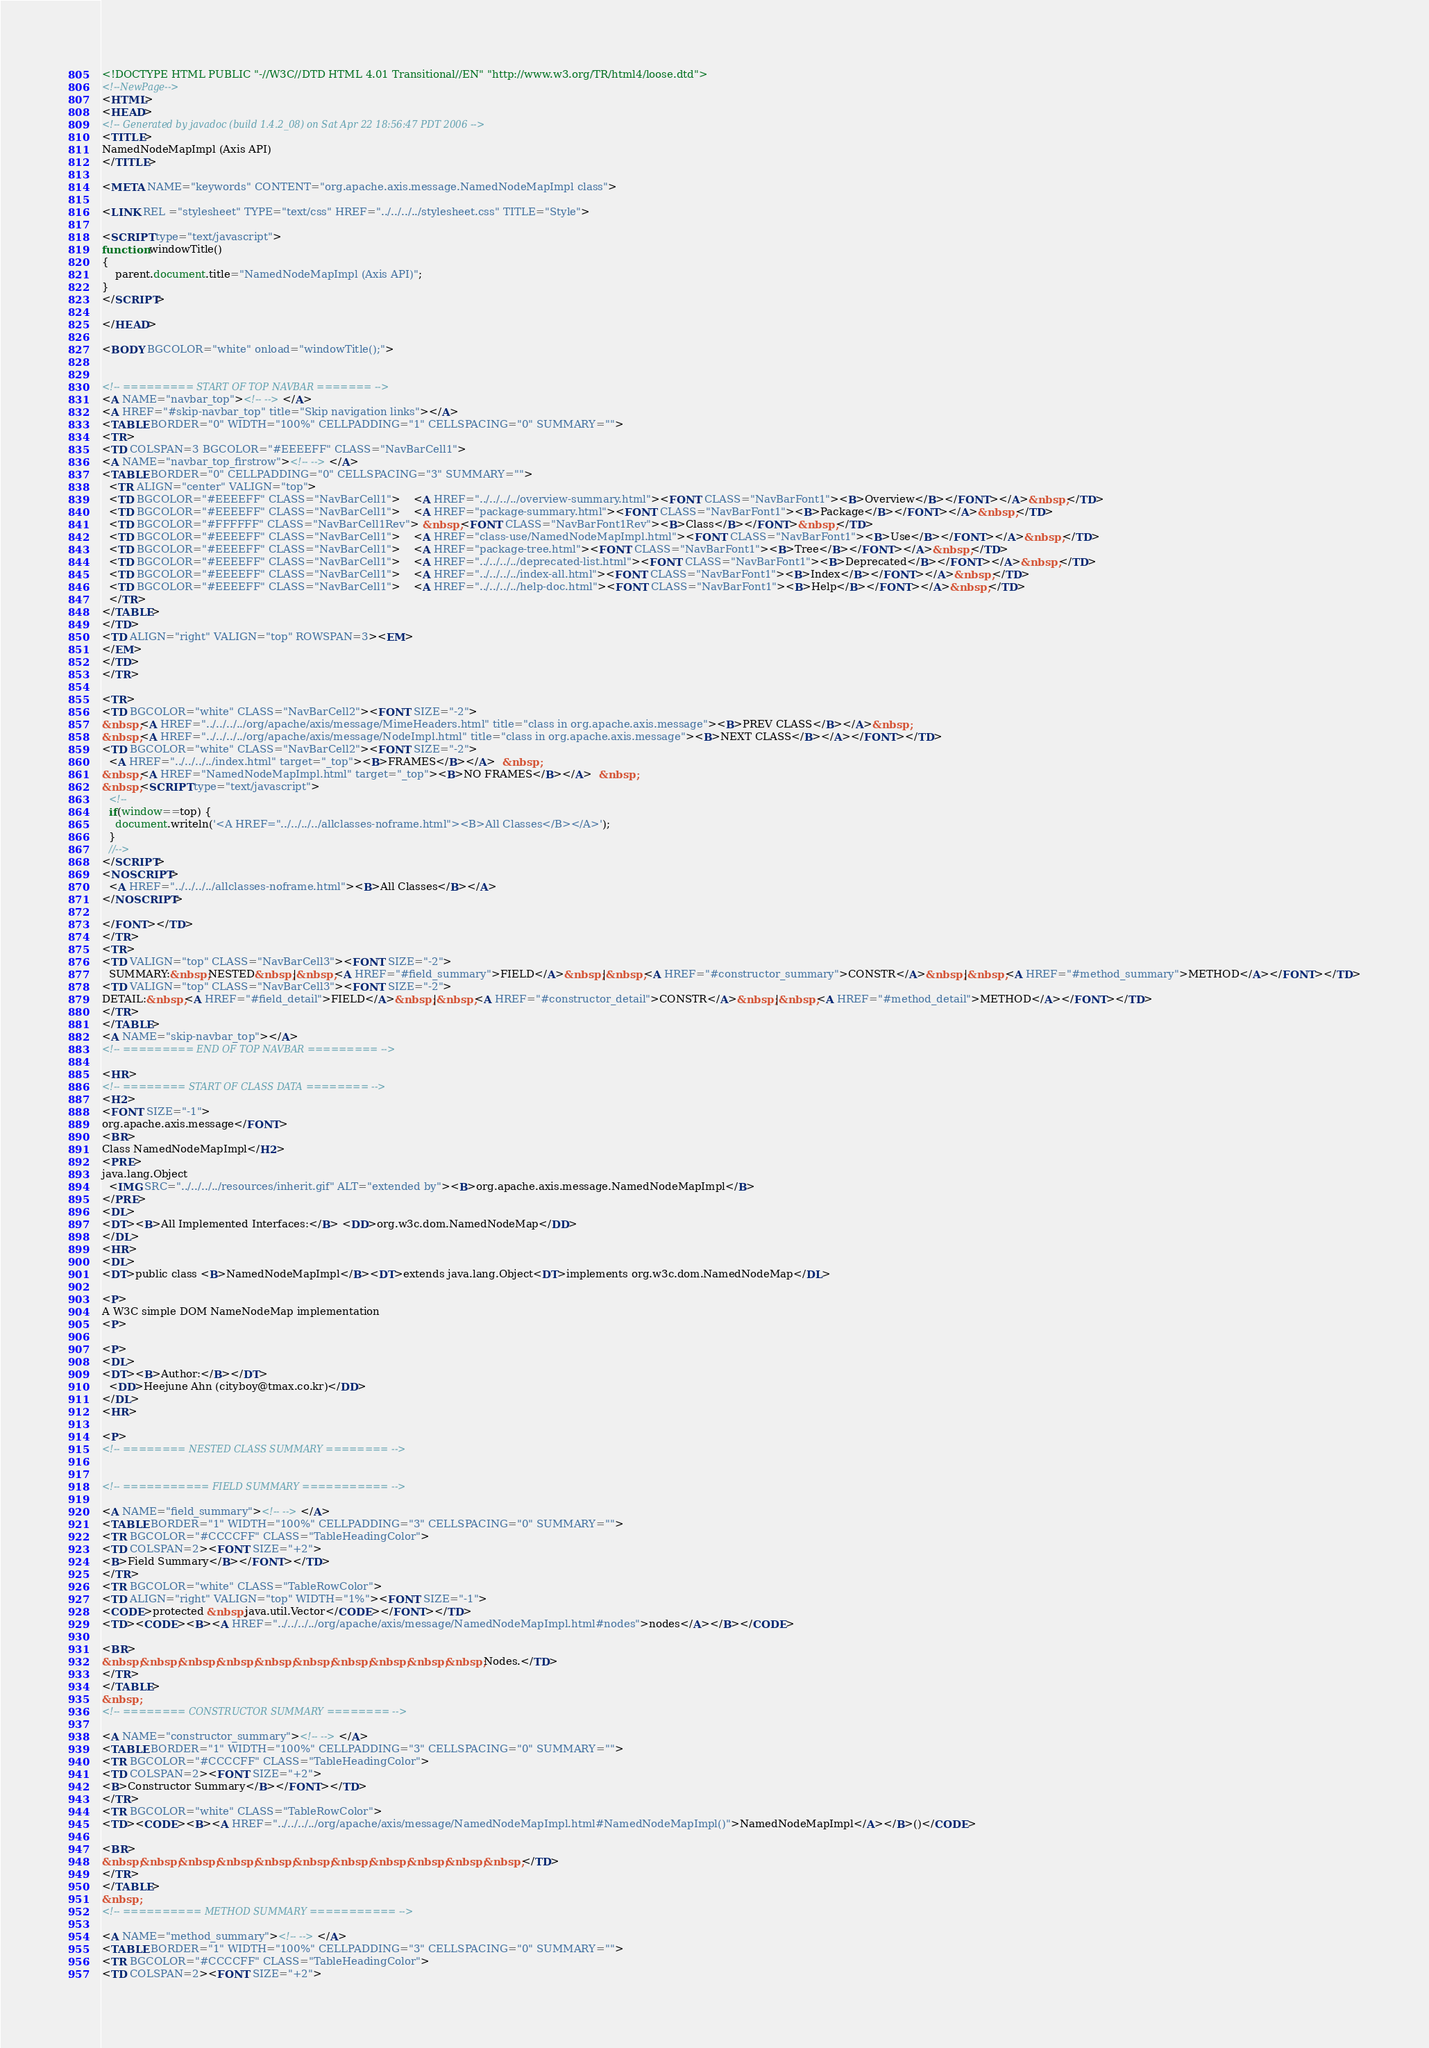<code> <loc_0><loc_0><loc_500><loc_500><_HTML_><!DOCTYPE HTML PUBLIC "-//W3C//DTD HTML 4.01 Transitional//EN" "http://www.w3.org/TR/html4/loose.dtd">
<!--NewPage-->
<HTML>
<HEAD>
<!-- Generated by javadoc (build 1.4.2_08) on Sat Apr 22 18:56:47 PDT 2006 -->
<TITLE>
NamedNodeMapImpl (Axis API)
</TITLE>

<META NAME="keywords" CONTENT="org.apache.axis.message.NamedNodeMapImpl class">

<LINK REL ="stylesheet" TYPE="text/css" HREF="../../../../stylesheet.css" TITLE="Style">

<SCRIPT type="text/javascript">
function windowTitle()
{
    parent.document.title="NamedNodeMapImpl (Axis API)";
}
</SCRIPT>

</HEAD>

<BODY BGCOLOR="white" onload="windowTitle();">


<!-- ========= START OF TOP NAVBAR ======= -->
<A NAME="navbar_top"><!-- --></A>
<A HREF="#skip-navbar_top" title="Skip navigation links"></A>
<TABLE BORDER="0" WIDTH="100%" CELLPADDING="1" CELLSPACING="0" SUMMARY="">
<TR>
<TD COLSPAN=3 BGCOLOR="#EEEEFF" CLASS="NavBarCell1">
<A NAME="navbar_top_firstrow"><!-- --></A>
<TABLE BORDER="0" CELLPADDING="0" CELLSPACING="3" SUMMARY="">
  <TR ALIGN="center" VALIGN="top">
  <TD BGCOLOR="#EEEEFF" CLASS="NavBarCell1">    <A HREF="../../../../overview-summary.html"><FONT CLASS="NavBarFont1"><B>Overview</B></FONT></A>&nbsp;</TD>
  <TD BGCOLOR="#EEEEFF" CLASS="NavBarCell1">    <A HREF="package-summary.html"><FONT CLASS="NavBarFont1"><B>Package</B></FONT></A>&nbsp;</TD>
  <TD BGCOLOR="#FFFFFF" CLASS="NavBarCell1Rev"> &nbsp;<FONT CLASS="NavBarFont1Rev"><B>Class</B></FONT>&nbsp;</TD>
  <TD BGCOLOR="#EEEEFF" CLASS="NavBarCell1">    <A HREF="class-use/NamedNodeMapImpl.html"><FONT CLASS="NavBarFont1"><B>Use</B></FONT></A>&nbsp;</TD>
  <TD BGCOLOR="#EEEEFF" CLASS="NavBarCell1">    <A HREF="package-tree.html"><FONT CLASS="NavBarFont1"><B>Tree</B></FONT></A>&nbsp;</TD>
  <TD BGCOLOR="#EEEEFF" CLASS="NavBarCell1">    <A HREF="../../../../deprecated-list.html"><FONT CLASS="NavBarFont1"><B>Deprecated</B></FONT></A>&nbsp;</TD>
  <TD BGCOLOR="#EEEEFF" CLASS="NavBarCell1">    <A HREF="../../../../index-all.html"><FONT CLASS="NavBarFont1"><B>Index</B></FONT></A>&nbsp;</TD>
  <TD BGCOLOR="#EEEEFF" CLASS="NavBarCell1">    <A HREF="../../../../help-doc.html"><FONT CLASS="NavBarFont1"><B>Help</B></FONT></A>&nbsp;</TD>
  </TR>
</TABLE>
</TD>
<TD ALIGN="right" VALIGN="top" ROWSPAN=3><EM>
</EM>
</TD>
</TR>

<TR>
<TD BGCOLOR="white" CLASS="NavBarCell2"><FONT SIZE="-2">
&nbsp;<A HREF="../../../../org/apache/axis/message/MimeHeaders.html" title="class in org.apache.axis.message"><B>PREV CLASS</B></A>&nbsp;
&nbsp;<A HREF="../../../../org/apache/axis/message/NodeImpl.html" title="class in org.apache.axis.message"><B>NEXT CLASS</B></A></FONT></TD>
<TD BGCOLOR="white" CLASS="NavBarCell2"><FONT SIZE="-2">
  <A HREF="../../../../index.html" target="_top"><B>FRAMES</B></A>  &nbsp;
&nbsp;<A HREF="NamedNodeMapImpl.html" target="_top"><B>NO FRAMES</B></A>  &nbsp;
&nbsp;<SCRIPT type="text/javascript">
  <!--
  if(window==top) {
    document.writeln('<A HREF="../../../../allclasses-noframe.html"><B>All Classes</B></A>');
  }
  //-->
</SCRIPT>
<NOSCRIPT>
  <A HREF="../../../../allclasses-noframe.html"><B>All Classes</B></A>
</NOSCRIPT>

</FONT></TD>
</TR>
<TR>
<TD VALIGN="top" CLASS="NavBarCell3"><FONT SIZE="-2">
  SUMMARY:&nbsp;NESTED&nbsp;|&nbsp;<A HREF="#field_summary">FIELD</A>&nbsp;|&nbsp;<A HREF="#constructor_summary">CONSTR</A>&nbsp;|&nbsp;<A HREF="#method_summary">METHOD</A></FONT></TD>
<TD VALIGN="top" CLASS="NavBarCell3"><FONT SIZE="-2">
DETAIL:&nbsp;<A HREF="#field_detail">FIELD</A>&nbsp;|&nbsp;<A HREF="#constructor_detail">CONSTR</A>&nbsp;|&nbsp;<A HREF="#method_detail">METHOD</A></FONT></TD>
</TR>
</TABLE>
<A NAME="skip-navbar_top"></A>
<!-- ========= END OF TOP NAVBAR ========= -->

<HR>
<!-- ======== START OF CLASS DATA ======== -->
<H2>
<FONT SIZE="-1">
org.apache.axis.message</FONT>
<BR>
Class NamedNodeMapImpl</H2>
<PRE>
java.lang.Object
  <IMG SRC="../../../../resources/inherit.gif" ALT="extended by"><B>org.apache.axis.message.NamedNodeMapImpl</B>
</PRE>
<DL>
<DT><B>All Implemented Interfaces:</B> <DD>org.w3c.dom.NamedNodeMap</DD>
</DL>
<HR>
<DL>
<DT>public class <B>NamedNodeMapImpl</B><DT>extends java.lang.Object<DT>implements org.w3c.dom.NamedNodeMap</DL>

<P>
A W3C simple DOM NameNodeMap implementation
<P>

<P>
<DL>
<DT><B>Author:</B></DT>
  <DD>Heejune Ahn (cityboy@tmax.co.kr)</DD>
</DL>
<HR>

<P>
<!-- ======== NESTED CLASS SUMMARY ======== -->


<!-- =========== FIELD SUMMARY =========== -->

<A NAME="field_summary"><!-- --></A>
<TABLE BORDER="1" WIDTH="100%" CELLPADDING="3" CELLSPACING="0" SUMMARY="">
<TR BGCOLOR="#CCCCFF" CLASS="TableHeadingColor">
<TD COLSPAN=2><FONT SIZE="+2">
<B>Field Summary</B></FONT></TD>
</TR>
<TR BGCOLOR="white" CLASS="TableRowColor">
<TD ALIGN="right" VALIGN="top" WIDTH="1%"><FONT SIZE="-1">
<CODE>protected &nbsp;java.util.Vector</CODE></FONT></TD>
<TD><CODE><B><A HREF="../../../../org/apache/axis/message/NamedNodeMapImpl.html#nodes">nodes</A></B></CODE>

<BR>
&nbsp;&nbsp;&nbsp;&nbsp;&nbsp;&nbsp;&nbsp;&nbsp;&nbsp;&nbsp;Nodes.</TD>
</TR>
</TABLE>
&nbsp;
<!-- ======== CONSTRUCTOR SUMMARY ======== -->

<A NAME="constructor_summary"><!-- --></A>
<TABLE BORDER="1" WIDTH="100%" CELLPADDING="3" CELLSPACING="0" SUMMARY="">
<TR BGCOLOR="#CCCCFF" CLASS="TableHeadingColor">
<TD COLSPAN=2><FONT SIZE="+2">
<B>Constructor Summary</B></FONT></TD>
</TR>
<TR BGCOLOR="white" CLASS="TableRowColor">
<TD><CODE><B><A HREF="../../../../org/apache/axis/message/NamedNodeMapImpl.html#NamedNodeMapImpl()">NamedNodeMapImpl</A></B>()</CODE>

<BR>
&nbsp;&nbsp;&nbsp;&nbsp;&nbsp;&nbsp;&nbsp;&nbsp;&nbsp;&nbsp;&nbsp;</TD>
</TR>
</TABLE>
&nbsp;
<!-- ========== METHOD SUMMARY =========== -->

<A NAME="method_summary"><!-- --></A>
<TABLE BORDER="1" WIDTH="100%" CELLPADDING="3" CELLSPACING="0" SUMMARY="">
<TR BGCOLOR="#CCCCFF" CLASS="TableHeadingColor">
<TD COLSPAN=2><FONT SIZE="+2"></code> 